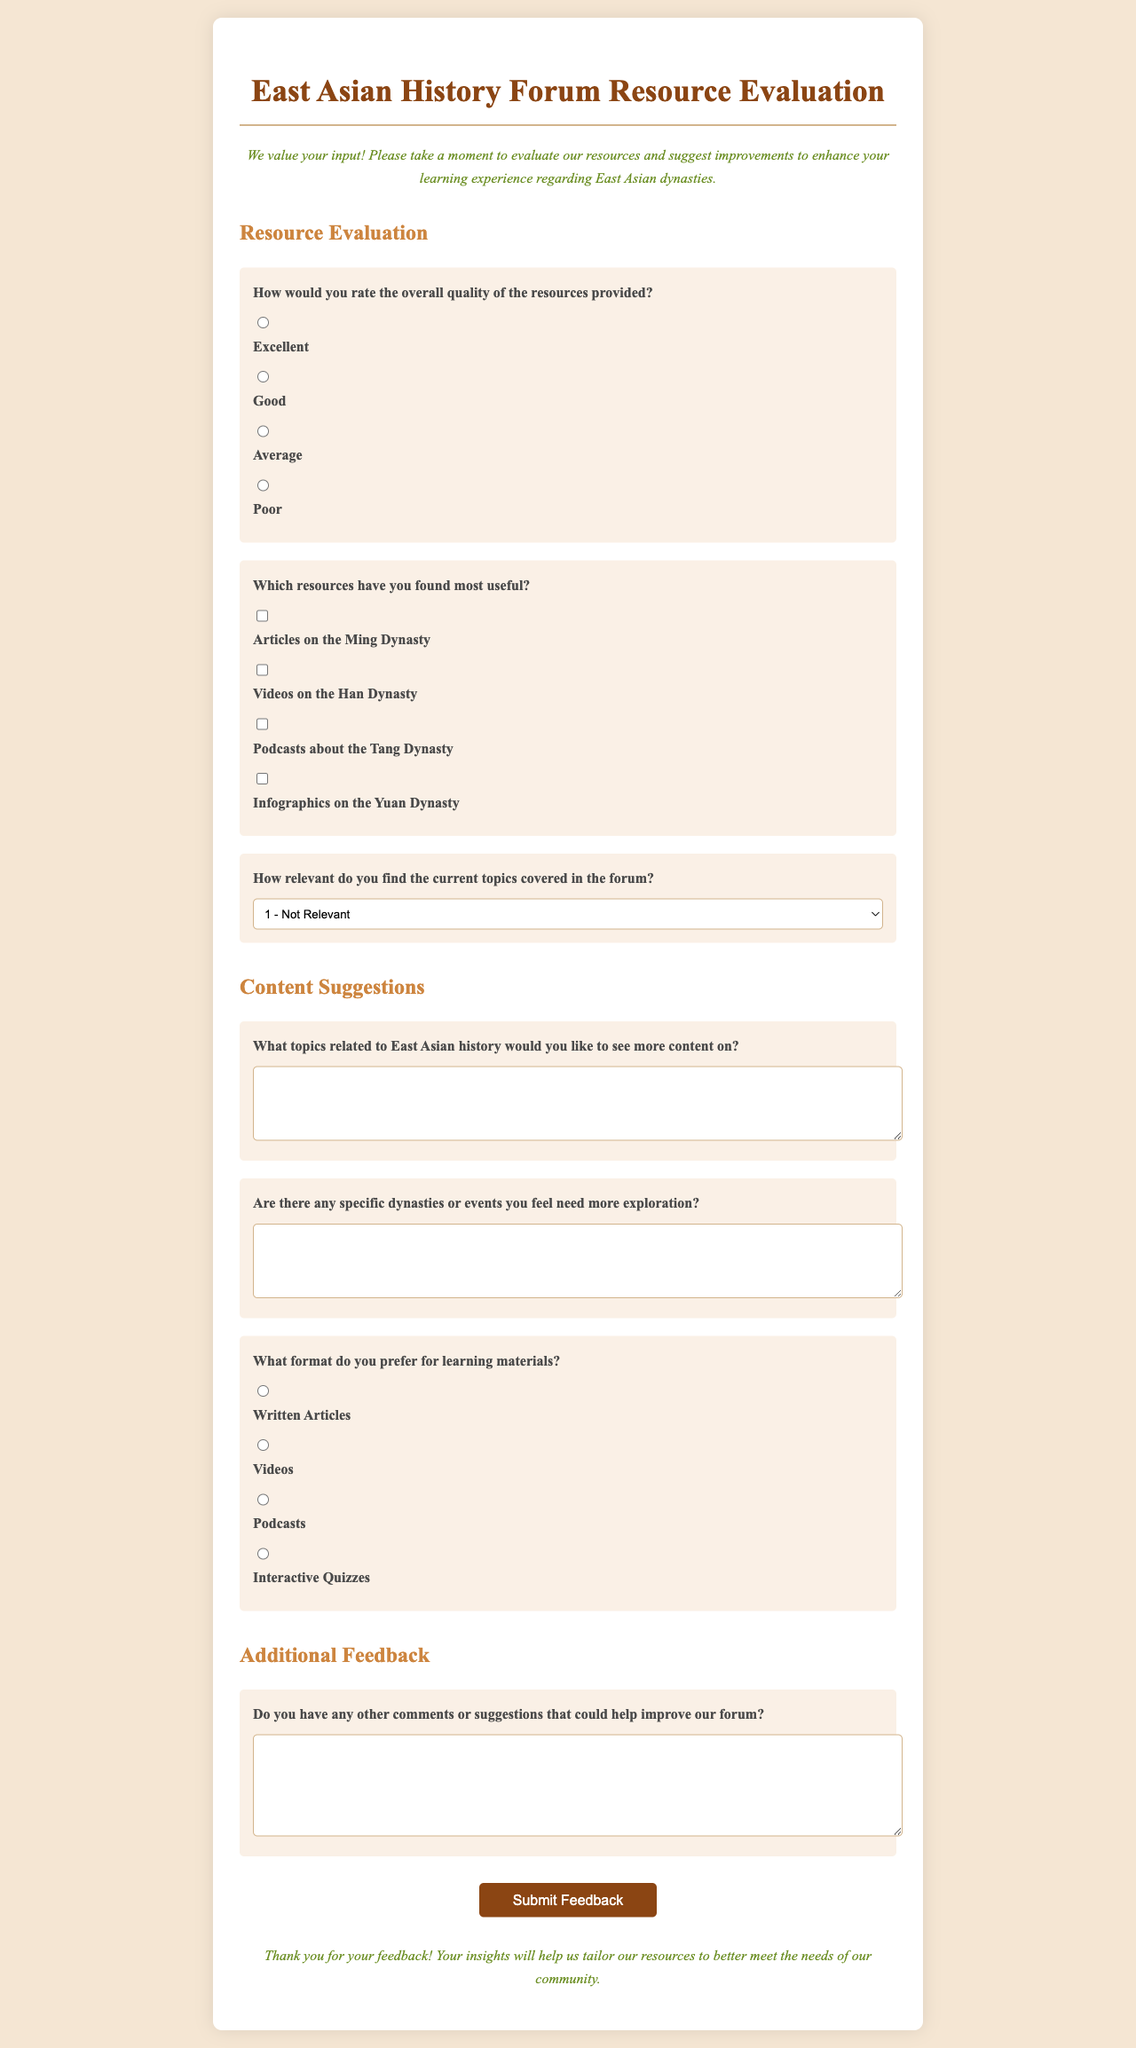What is the title of the feedback form? The title is specifically stated at the top of the document.
Answer: East Asian History Forum Resource Evaluation What is the main introduction or purpose of the form? The introduction explains the reason for the evaluation and what the forum values.
Answer: We value your input! Please take a moment to evaluate our resources and suggest improvements to enhance your learning experience regarding East Asian dynasties How many options are provided for rating the overall quality of resources? The document lists the number of rating options available for evaluation.
Answer: Four What is one of the suggested resources mentioned in the useful resource section? The document lists specific types of resources that respondents can choose from.
Answer: Articles on the Ming Dynasty What format option is NOT included in the preferences for learning materials? The question requires an understanding of the formats listed in the document and what is missing.
Answer: E-books 